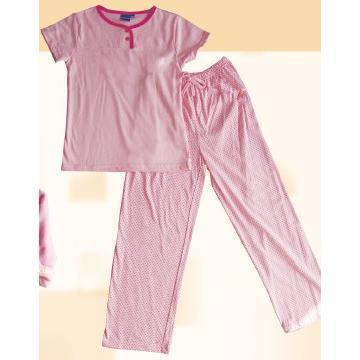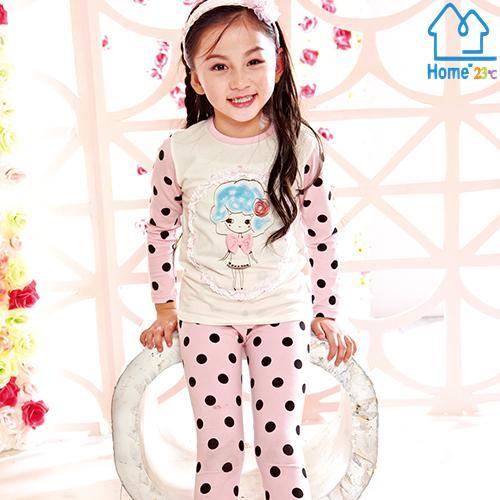The first image is the image on the left, the second image is the image on the right. Given the left and right images, does the statement "At least 1 child is wearing blue patterned pajamas." hold true? Answer yes or no. No. The first image is the image on the left, the second image is the image on the right. For the images displayed, is the sentence "There is more than one child in total." factually correct? Answer yes or no. No. 